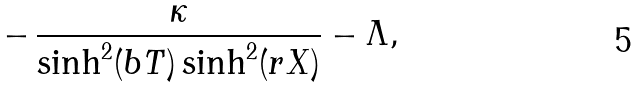Convert formula to latex. <formula><loc_0><loc_0><loc_500><loc_500>- \, \frac { \kappa } { \sinh ^ { 2 } ( b T ) \sinh ^ { 2 } ( r X ) } - \Lambda ,</formula> 